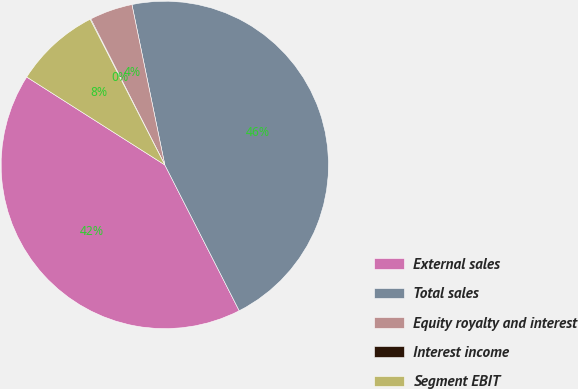Convert chart to OTSL. <chart><loc_0><loc_0><loc_500><loc_500><pie_chart><fcel>External sales<fcel>Total sales<fcel>Equity royalty and interest<fcel>Interest income<fcel>Segment EBIT<nl><fcel>41.53%<fcel>45.71%<fcel>4.25%<fcel>0.07%<fcel>8.44%<nl></chart> 